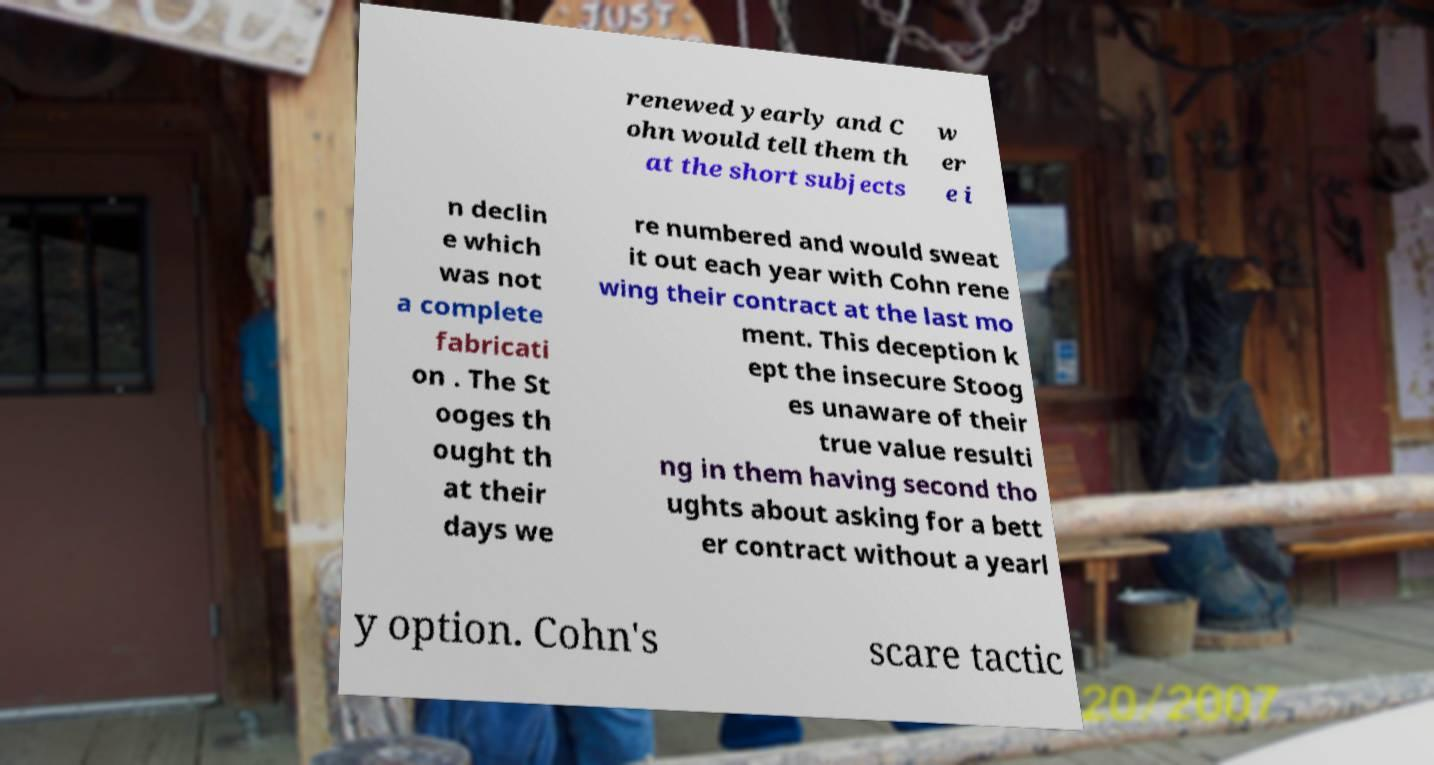Could you assist in decoding the text presented in this image and type it out clearly? renewed yearly and C ohn would tell them th at the short subjects w er e i n declin e which was not a complete fabricati on . The St ooges th ought th at their days we re numbered and would sweat it out each year with Cohn rene wing their contract at the last mo ment. This deception k ept the insecure Stoog es unaware of their true value resulti ng in them having second tho ughts about asking for a bett er contract without a yearl y option. Cohn's scare tactic 